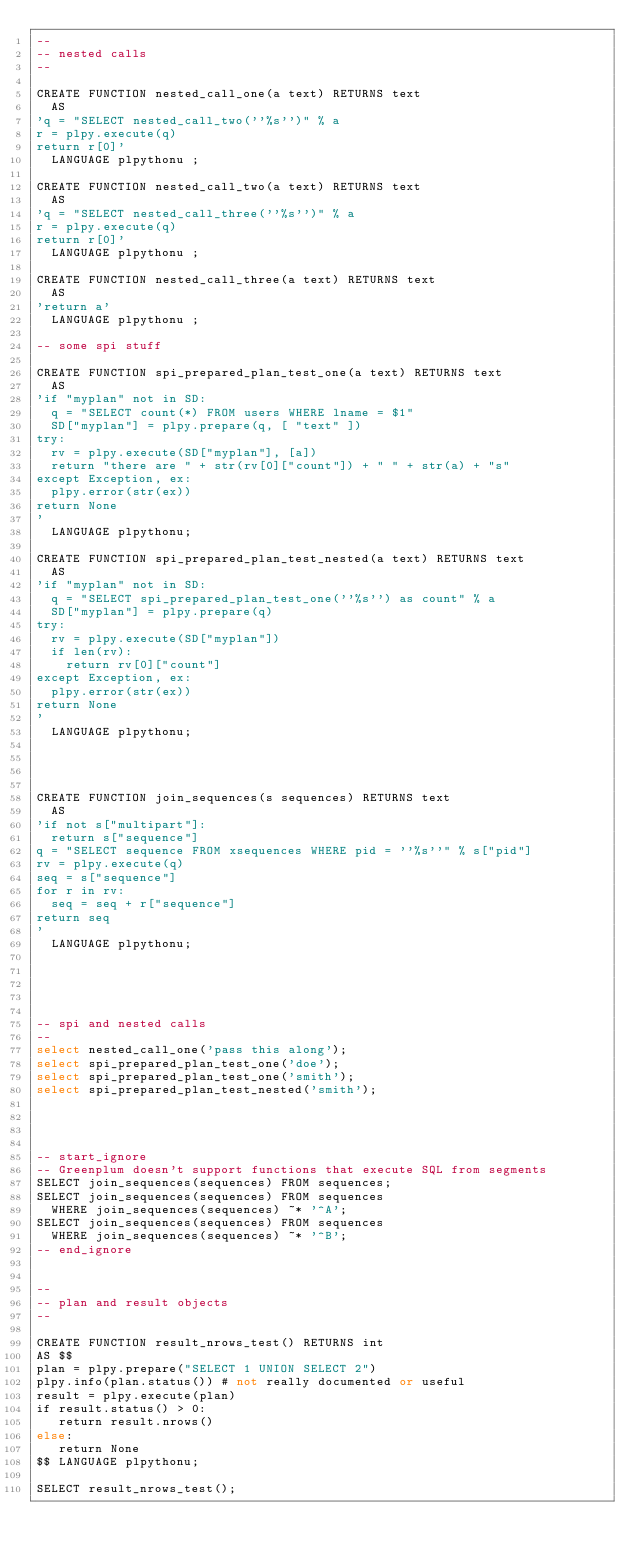<code> <loc_0><loc_0><loc_500><loc_500><_SQL_>--
-- nested calls
--

CREATE FUNCTION nested_call_one(a text) RETURNS text
	AS
'q = "SELECT nested_call_two(''%s'')" % a
r = plpy.execute(q)
return r[0]'
	LANGUAGE plpythonu ;

CREATE FUNCTION nested_call_two(a text) RETURNS text
	AS
'q = "SELECT nested_call_three(''%s'')" % a
r = plpy.execute(q)
return r[0]'
	LANGUAGE plpythonu ;

CREATE FUNCTION nested_call_three(a text) RETURNS text
	AS
'return a'
	LANGUAGE plpythonu ;

-- some spi stuff

CREATE FUNCTION spi_prepared_plan_test_one(a text) RETURNS text
	AS
'if "myplan" not in SD:
	q = "SELECT count(*) FROM users WHERE lname = $1"
	SD["myplan"] = plpy.prepare(q, [ "text" ])
try:
	rv = plpy.execute(SD["myplan"], [a])
	return "there are " + str(rv[0]["count"]) + " " + str(a) + "s"
except Exception, ex:
	plpy.error(str(ex))
return None
'
	LANGUAGE plpythonu;

CREATE FUNCTION spi_prepared_plan_test_nested(a text) RETURNS text
	AS
'if "myplan" not in SD:
	q = "SELECT spi_prepared_plan_test_one(''%s'') as count" % a
	SD["myplan"] = plpy.prepare(q)
try:
	rv = plpy.execute(SD["myplan"])
	if len(rv):
		return rv[0]["count"]
except Exception, ex:
	plpy.error(str(ex))
return None
'
	LANGUAGE plpythonu;




CREATE FUNCTION join_sequences(s sequences) RETURNS text
	AS
'if not s["multipart"]:
	return s["sequence"]
q = "SELECT sequence FROM xsequences WHERE pid = ''%s''" % s["pid"]
rv = plpy.execute(q)
seq = s["sequence"]
for r in rv:
	seq = seq + r["sequence"]
return seq
'
	LANGUAGE plpythonu;





-- spi and nested calls
--
select nested_call_one('pass this along');
select spi_prepared_plan_test_one('doe');
select spi_prepared_plan_test_one('smith');
select spi_prepared_plan_test_nested('smith');




-- start_ignore
-- Greenplum doesn't support functions that execute SQL from segments
SELECT join_sequences(sequences) FROM sequences;
SELECT join_sequences(sequences) FROM sequences
	WHERE join_sequences(sequences) ~* '^A';
SELECT join_sequences(sequences) FROM sequences
	WHERE join_sequences(sequences) ~* '^B';
-- end_ignore


--
-- plan and result objects
--

CREATE FUNCTION result_nrows_test() RETURNS int
AS $$
plan = plpy.prepare("SELECT 1 UNION SELECT 2")
plpy.info(plan.status()) # not really documented or useful
result = plpy.execute(plan)
if result.status() > 0:
   return result.nrows()
else:
   return None
$$ LANGUAGE plpythonu;

SELECT result_nrows_test();
</code> 